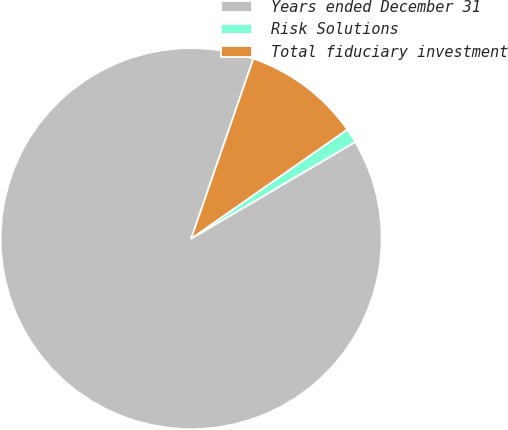<chart> <loc_0><loc_0><loc_500><loc_500><pie_chart><fcel>Years ended December 31<fcel>Risk Solutions<fcel>Total fiduciary investment<nl><fcel>88.78%<fcel>1.23%<fcel>9.99%<nl></chart> 